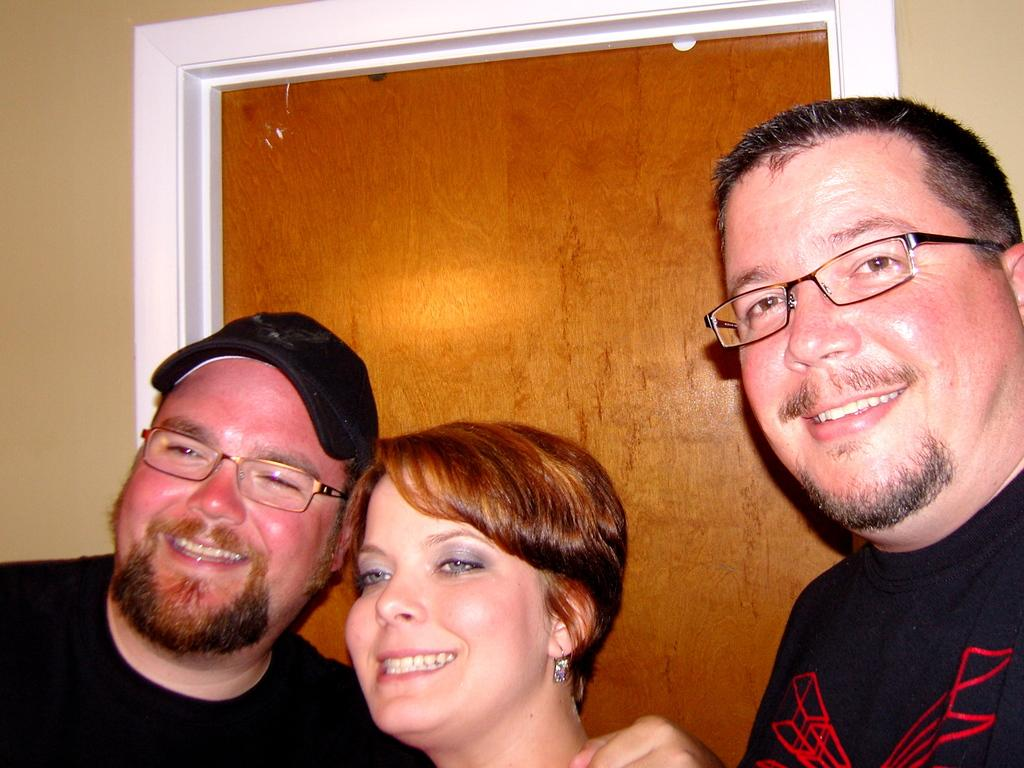How many people are in the image? There are two men and a woman in the image, making a total of three people. What is the facial expression of the individuals in the image? The individuals in the image are smiling. Can you describe any accessories worn by the people in the image? Some people in the image are wearing spectacles. Can you see any feathers on the deer in the image? There is no deer present in the image, and therefore no feathers can be seen. What impulse might have caused the individuals to smile in the image? It is impossible to determine the reason for their smiles from the image alone. 